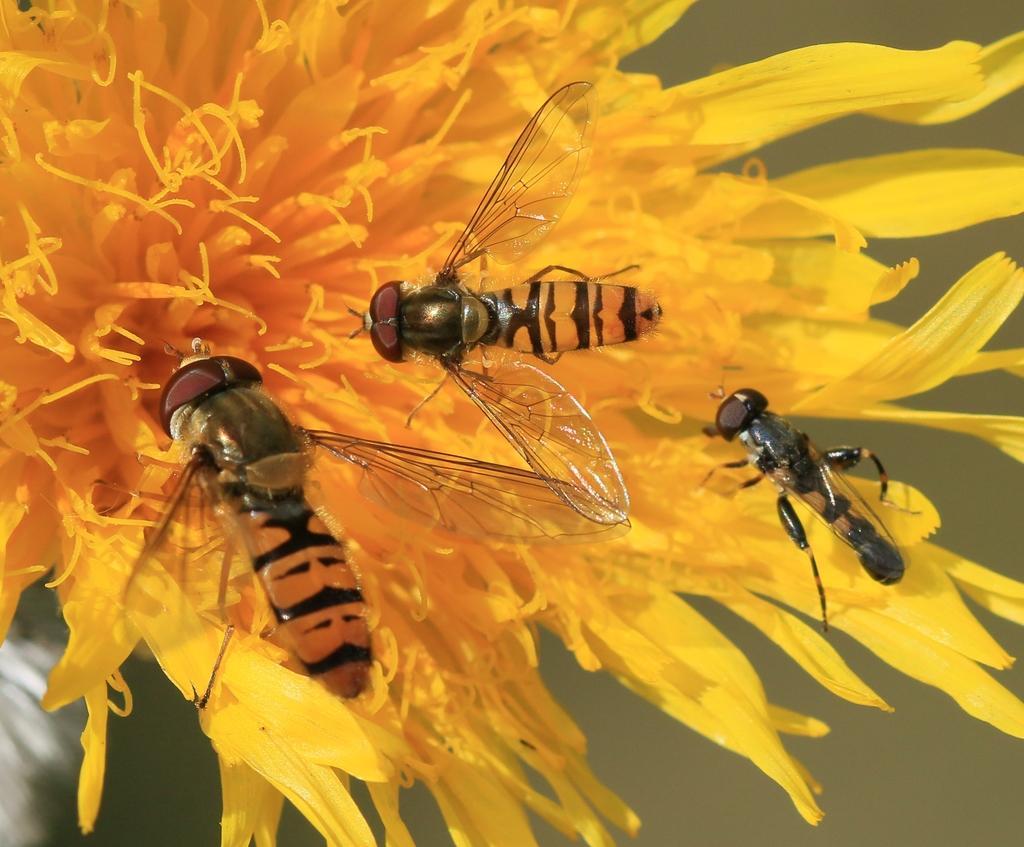Could you give a brief overview of what you see in this image? In the image I can see three flies on the flower which is in yellow color. 